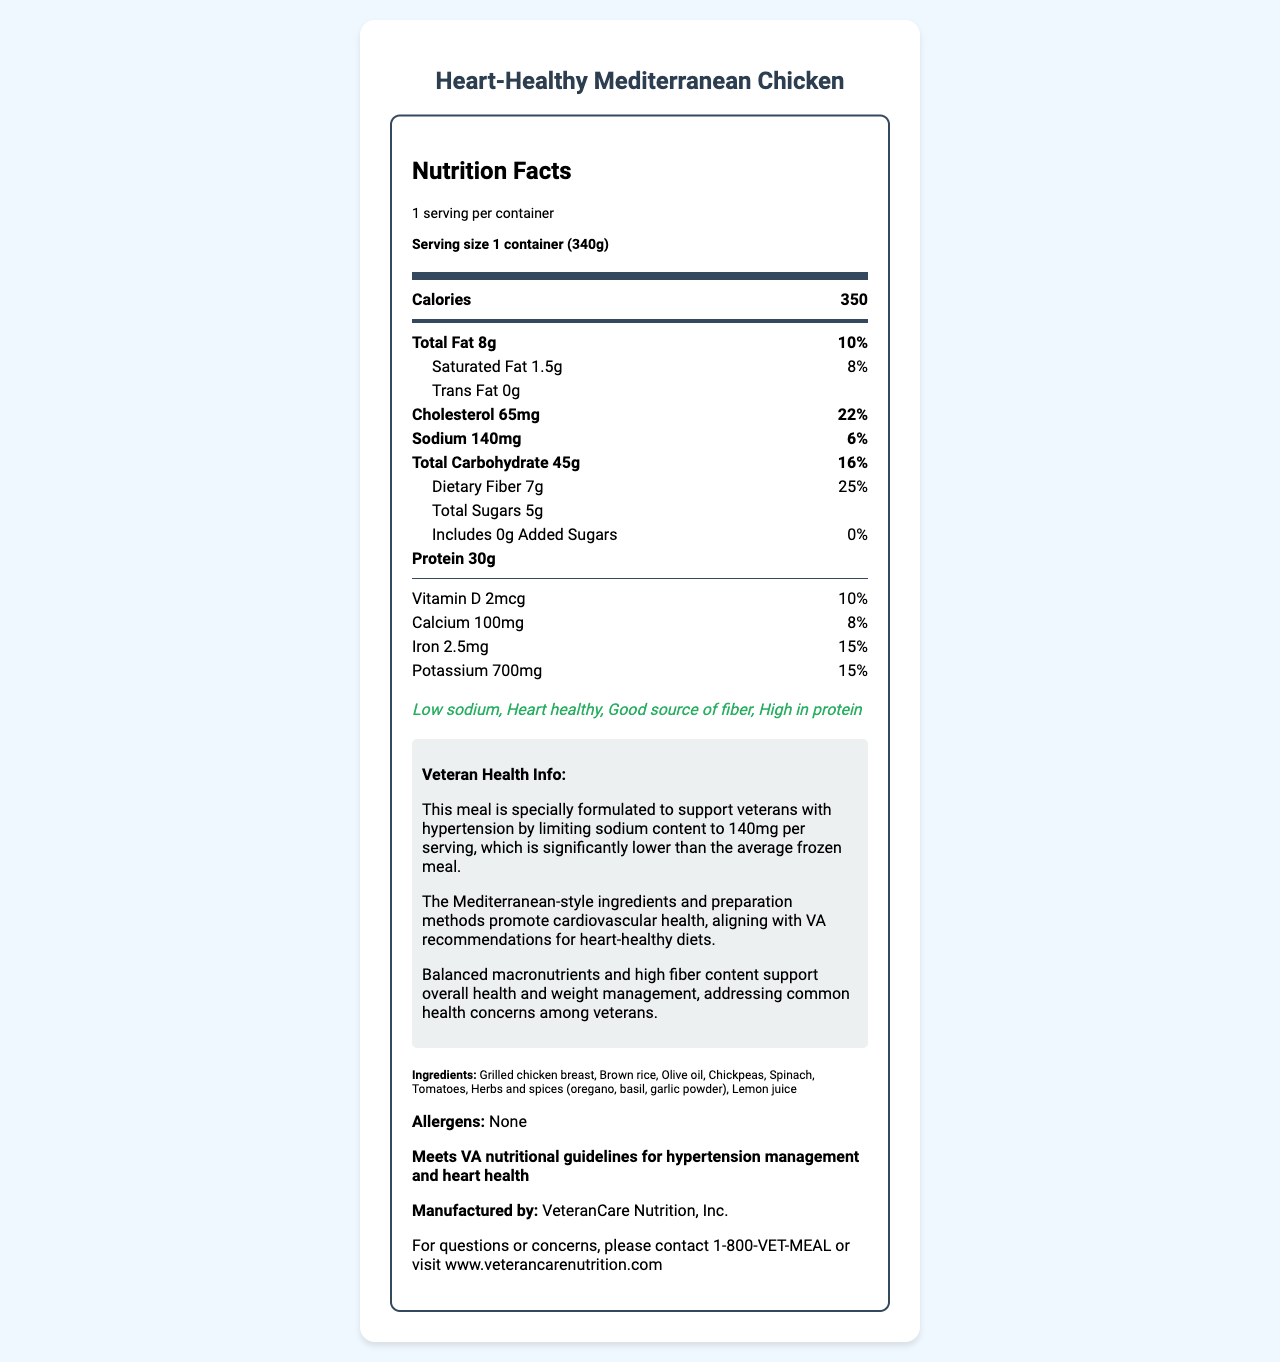what is the serving size? The serving size is explicitly mentioned in the document under the serving information section as "1 container (340g)".
Answer: 1 container (340g) how many calories are in one serving? The document states the calorie content under the section labeled 'Calories'.
Answer: 350 how much sodium does this meal contain? The sodium content is listed under the 'Sodium' section as 140mg.
Answer: 140mg which ingredient is not in this meal? A. Olive oil B. Spinach C. Cheese D. Chickpeas The ingredient list includes grilled chicken breast, brown rice, olive oil, chickpeas, spinach, tomatoes, herbs and spices, and lemon juice. Cheese is not listed as an ingredient.
Answer: C how much protein is in this meal? The amount of protein is specified in the document as 30g.
Answer: 30g does this meal contain any added sugars? The document indicates that added sugars are 0g, which means there are no added sugars.
Answer: No what percentage of daily fiber does this meal provide? The daily value percentage for dietary fiber is provided as 25% in the document.
Answer: 25% how much iron is present in this meal? The amount of iron is presented as 2.5mg in the document.
Answer: 2.5mg which vitamins and minerals are listed in this meal? A. Vitamin D, Calcium, Iron, Potassium B. Vitamin A, Vitamin C, Iron, Potassium C. Calcium, Iron, Magnesium, Sodium The document lists Vitamin D, Calcium, Iron, and Potassium with their respective amounts and daily values.
Answer: A what is the total amount of fat in this meal? The total fat content is mentioned in the document as 8g.
Answer: 8g is this meal approved by the VA for hypertension management and heart health? The document states that it meets VA nutritional guidelines for hypertension management and heart health.
Answer: Yes describe the main idea of this document. The document primarily outlines the nutritional profile of the product and emphasizes its suitability for veterans with hypertension and heart health concerns, along with VA approval.
Answer: The document provides detailed nutrition information for the "Heart-Healthy Mediterranean Chicken", a low-sodium, heart-healthy frozen meal. It includes data on calories, macronutrients, vitamins, and minerals, and highlights the meal's health benefits for veterans with hypertension. The meal meets VA guidelines and is manufactured by VeteranCare Nutrition, Inc. what company manufactures this meal? The manufacturer's name is listed at the end of the document as VeteranCare Nutrition, Inc.
Answer: VeteranCare Nutrition, Inc. how much cholesterol does the meal contain, and what is its daily value percentage? The document states that the cholesterol content is 65mg, which corresponds to 22% of the daily value.
Answer: 65mg, 22% what is the contact information provided for questions or concerns? The document gives the contact number and website as the means for inquiries.
Answer: 1-800-VET-MEAL or visit www.veterancarenutrition.com why is this meal considered heart-healthy? The document explains that the ingredients and methods of preparation support cardiovascular health, which is why it is labeled heart-healthy.
Answer: The meal uses Mediterranean-style ingredients and preparation methods that promote cardiovascular health, aligning with VA recommendations for heart-healthy diets. how can this meal support veterans with hypertension? The veteran health info section clearly states that the low sodium content is aimed at supporting hypertension management.
Answer: This meal supports veterans with hypertension by limiting sodium content to 140mg per serving, which is much lower than average frozen meals. who should be avoided due to allergens in this meal? The document mentions that there are no allergens listed, therefore it cannot determine who should avoid it based on allergen content.
Answer: I don't know 